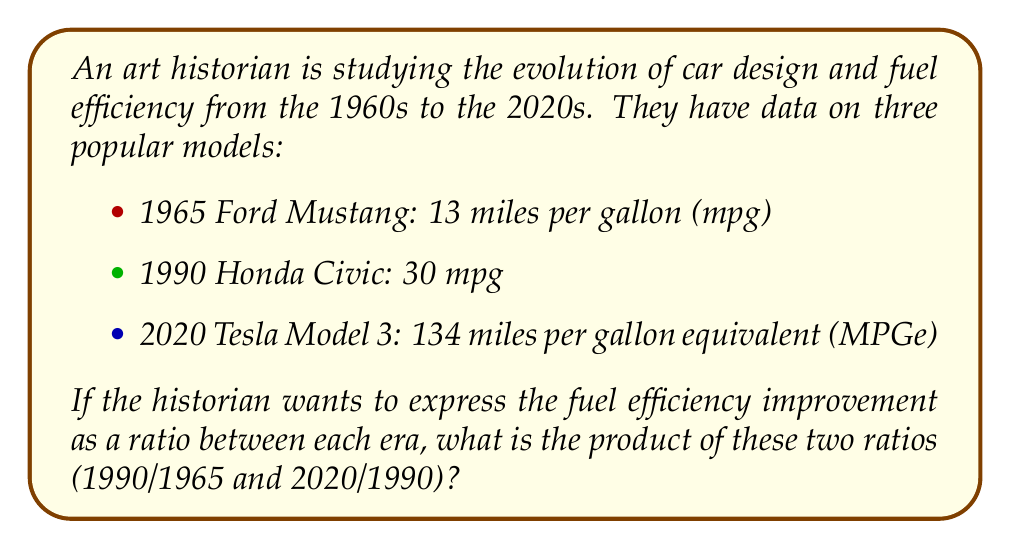What is the answer to this math problem? Let's approach this step-by-step:

1. First, we need to calculate the ratio of fuel efficiency improvement from 1965 to 1990:
   $$ \text{Ratio}_1 = \frac{1990 \text{ Honda Civic efficiency}}{1965 \text{ Ford Mustang efficiency}} = \frac{30 \text{ mpg}}{13 \text{ mpg}} = \frac{30}{13} \approx 2.31 $$

2. Next, we calculate the ratio of fuel efficiency improvement from 1990 to 2020:
   $$ \text{Ratio}_2 = \frac{2020 \text{ Tesla Model 3 efficiency}}{1990 \text{ Honda Civic efficiency}} = \frac{134 \text{ MPGe}}{30 \text{ mpg}} = \frac{134}{30} \approx 4.47 $$

3. The question asks for the product of these two ratios:
   $$ \text{Product} = \text{Ratio}_1 \times \text{Ratio}_2 = \frac{30}{13} \times \frac{134}{30} $$

4. We can simplify this calculation:
   $$ \text{Product} = \frac{30 \times 134}{13 \times 30} = \frac{134}{13} \approx 10.31 $$

This result shows that the overall improvement in fuel efficiency from 1965 to 2020 is about 10.31 times.
Answer: $\frac{134}{13}$ or approximately 10.31 